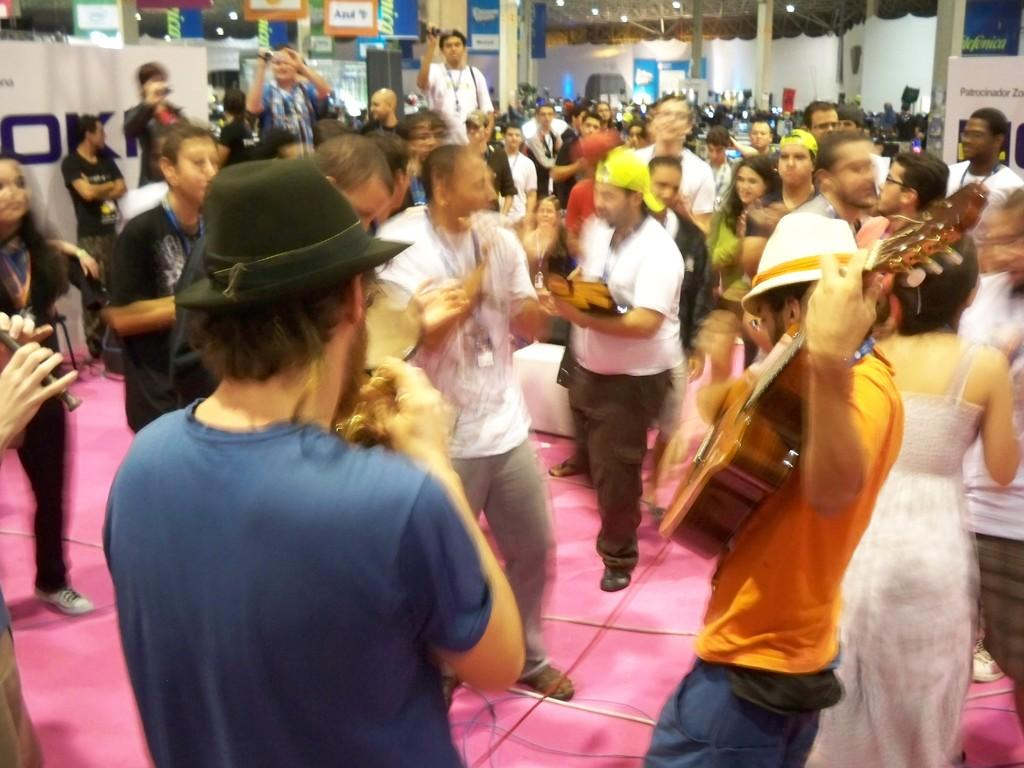How many people are in the image? There is a group of people standing in the image, but the exact number is not specified. What are the people standing on? The people are standing on the floor. What musical instrument can be seen in the image? There is a guitar in the image. What type of headwear is present in the image? There are caps in the image. What devices are used to capture images in the image? There are cameras in the image. What type of decorations are present in the image? There are posters in the image. What architectural elements can be seen in the image? There are pillars in the image. What type of lighting is present in the image? There are lights in the image. What unspecified objects can be seen in the image? There are some unspecified objects in the image. What is visible in the background of the image? There is a wall in the background of the image. Can you tell me how many sea bears are visible in the image? There are no sea bears present in the image. What is the sum of the number of people and the number of unspecified objects in the image? The exact number of people and unspecified objects is not specified, so it is not possible to calculate their sum. 